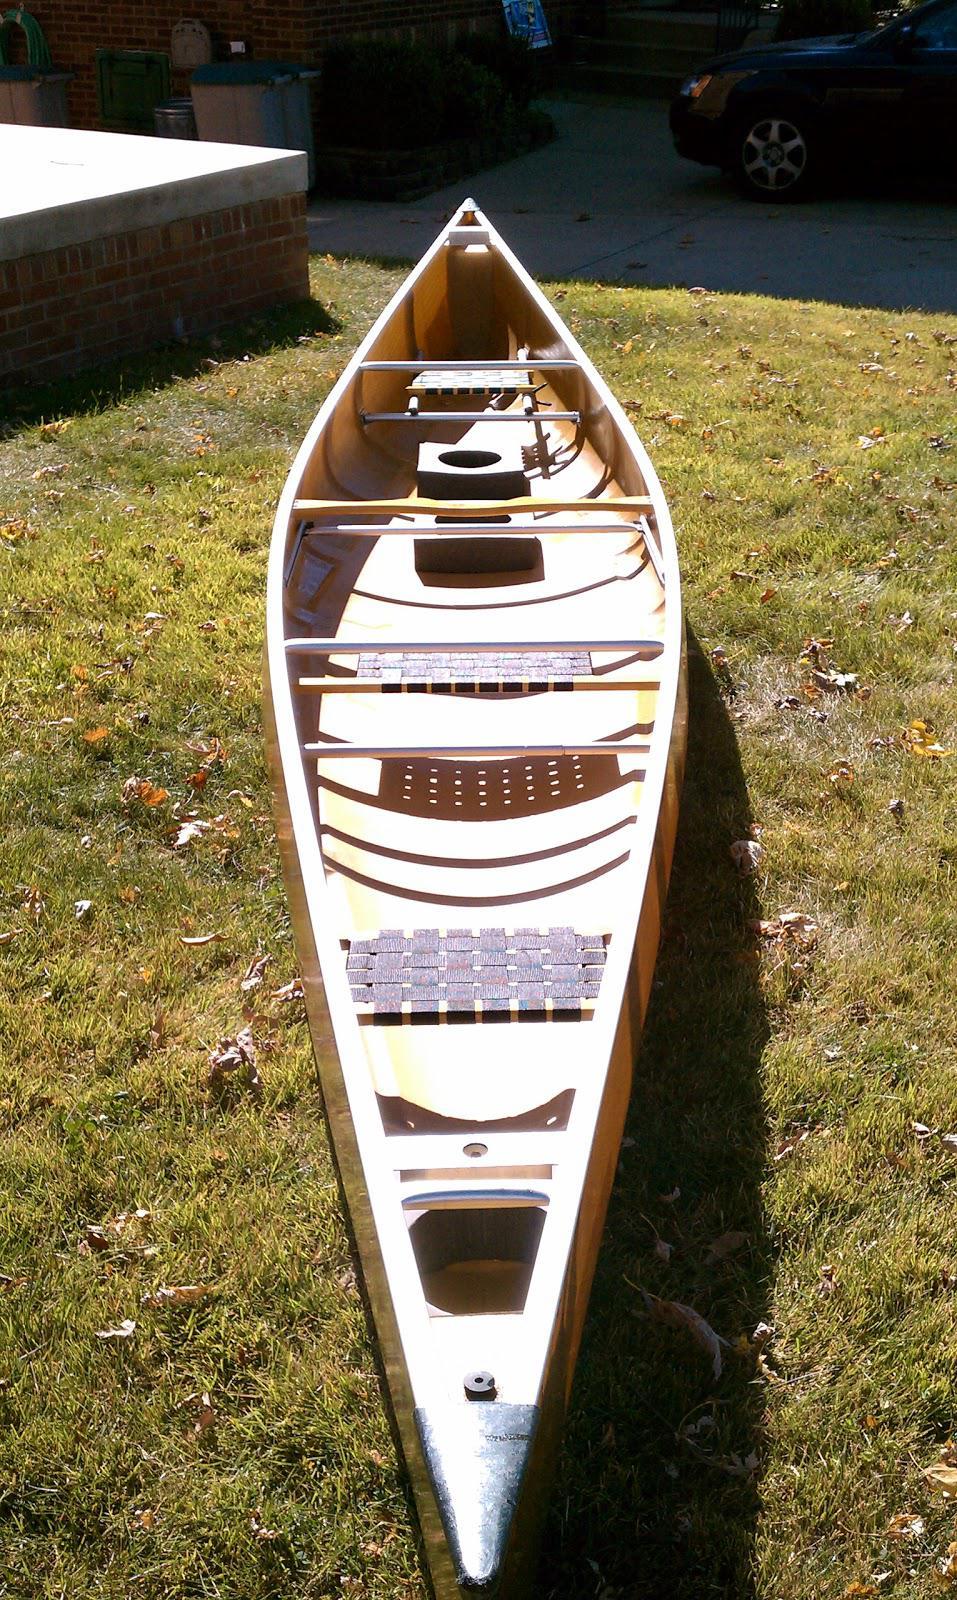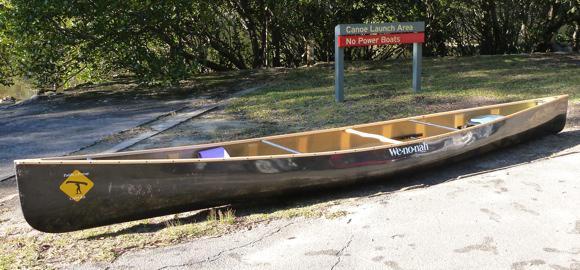The first image is the image on the left, the second image is the image on the right. Examine the images to the left and right. Is the description "Two canoes are sitting on the ground." accurate? Answer yes or no. Yes. The first image is the image on the left, the second image is the image on the right. Assess this claim about the two images: "The left and right image contains the same number of boat on land.". Correct or not? Answer yes or no. Yes. 